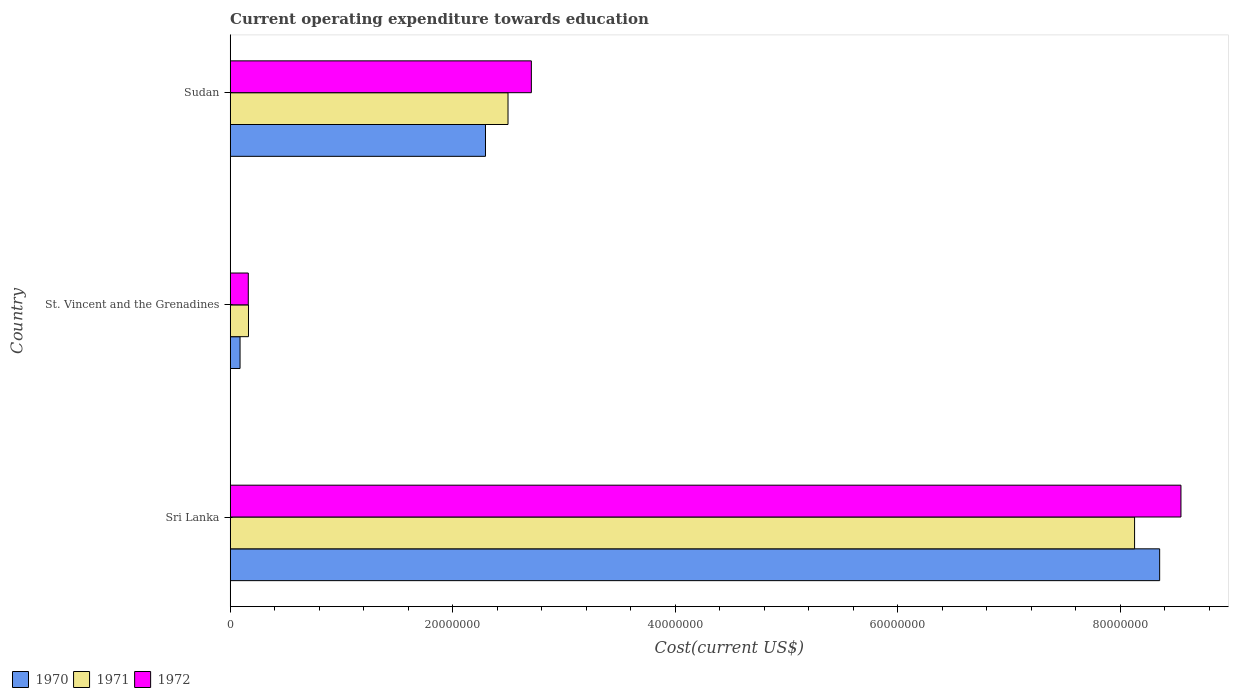How many different coloured bars are there?
Make the answer very short. 3. Are the number of bars on each tick of the Y-axis equal?
Ensure brevity in your answer.  Yes. How many bars are there on the 3rd tick from the bottom?
Keep it short and to the point. 3. What is the label of the 2nd group of bars from the top?
Your answer should be very brief. St. Vincent and the Grenadines. In how many cases, is the number of bars for a given country not equal to the number of legend labels?
Provide a short and direct response. 0. What is the expenditure towards education in 1970 in St. Vincent and the Grenadines?
Ensure brevity in your answer.  8.86e+05. Across all countries, what is the maximum expenditure towards education in 1970?
Keep it short and to the point. 8.35e+07. Across all countries, what is the minimum expenditure towards education in 1971?
Offer a very short reply. 1.64e+06. In which country was the expenditure towards education in 1970 maximum?
Offer a very short reply. Sri Lanka. In which country was the expenditure towards education in 1972 minimum?
Provide a short and direct response. St. Vincent and the Grenadines. What is the total expenditure towards education in 1972 in the graph?
Offer a very short reply. 1.14e+08. What is the difference between the expenditure towards education in 1971 in St. Vincent and the Grenadines and that in Sudan?
Make the answer very short. -2.33e+07. What is the difference between the expenditure towards education in 1971 in Sudan and the expenditure towards education in 1972 in St. Vincent and the Grenadines?
Your answer should be compact. 2.33e+07. What is the average expenditure towards education in 1972 per country?
Keep it short and to the point. 3.81e+07. What is the difference between the expenditure towards education in 1970 and expenditure towards education in 1972 in St. Vincent and the Grenadines?
Make the answer very short. -7.42e+05. What is the ratio of the expenditure towards education in 1972 in Sri Lanka to that in St. Vincent and the Grenadines?
Make the answer very short. 52.51. Is the expenditure towards education in 1972 in Sri Lanka less than that in St. Vincent and the Grenadines?
Offer a terse response. No. What is the difference between the highest and the second highest expenditure towards education in 1971?
Offer a very short reply. 5.63e+07. What is the difference between the highest and the lowest expenditure towards education in 1970?
Ensure brevity in your answer.  8.27e+07. What does the 3rd bar from the bottom in Sudan represents?
Provide a succinct answer. 1972. Is it the case that in every country, the sum of the expenditure towards education in 1970 and expenditure towards education in 1972 is greater than the expenditure towards education in 1971?
Give a very brief answer. Yes. Are all the bars in the graph horizontal?
Provide a short and direct response. Yes. What is the difference between two consecutive major ticks on the X-axis?
Your response must be concise. 2.00e+07. Are the values on the major ticks of X-axis written in scientific E-notation?
Give a very brief answer. No. Does the graph contain any zero values?
Make the answer very short. No. What is the title of the graph?
Provide a short and direct response. Current operating expenditure towards education. Does "1960" appear as one of the legend labels in the graph?
Provide a short and direct response. No. What is the label or title of the X-axis?
Give a very brief answer. Cost(current US$). What is the label or title of the Y-axis?
Offer a very short reply. Country. What is the Cost(current US$) in 1970 in Sri Lanka?
Make the answer very short. 8.35e+07. What is the Cost(current US$) of 1971 in Sri Lanka?
Provide a succinct answer. 8.13e+07. What is the Cost(current US$) of 1972 in Sri Lanka?
Make the answer very short. 8.55e+07. What is the Cost(current US$) of 1970 in St. Vincent and the Grenadines?
Make the answer very short. 8.86e+05. What is the Cost(current US$) in 1971 in St. Vincent and the Grenadines?
Keep it short and to the point. 1.64e+06. What is the Cost(current US$) in 1972 in St. Vincent and the Grenadines?
Provide a short and direct response. 1.63e+06. What is the Cost(current US$) in 1970 in Sudan?
Your answer should be compact. 2.29e+07. What is the Cost(current US$) of 1971 in Sudan?
Offer a terse response. 2.50e+07. What is the Cost(current US$) of 1972 in Sudan?
Offer a very short reply. 2.71e+07. Across all countries, what is the maximum Cost(current US$) in 1970?
Ensure brevity in your answer.  8.35e+07. Across all countries, what is the maximum Cost(current US$) in 1971?
Provide a succinct answer. 8.13e+07. Across all countries, what is the maximum Cost(current US$) in 1972?
Offer a very short reply. 8.55e+07. Across all countries, what is the minimum Cost(current US$) in 1970?
Give a very brief answer. 8.86e+05. Across all countries, what is the minimum Cost(current US$) of 1971?
Provide a succinct answer. 1.64e+06. Across all countries, what is the minimum Cost(current US$) of 1972?
Keep it short and to the point. 1.63e+06. What is the total Cost(current US$) of 1970 in the graph?
Ensure brevity in your answer.  1.07e+08. What is the total Cost(current US$) of 1971 in the graph?
Keep it short and to the point. 1.08e+08. What is the total Cost(current US$) in 1972 in the graph?
Provide a succinct answer. 1.14e+08. What is the difference between the Cost(current US$) of 1970 in Sri Lanka and that in St. Vincent and the Grenadines?
Ensure brevity in your answer.  8.27e+07. What is the difference between the Cost(current US$) of 1971 in Sri Lanka and that in St. Vincent and the Grenadines?
Your response must be concise. 7.96e+07. What is the difference between the Cost(current US$) in 1972 in Sri Lanka and that in St. Vincent and the Grenadines?
Keep it short and to the point. 8.38e+07. What is the difference between the Cost(current US$) in 1970 in Sri Lanka and that in Sudan?
Ensure brevity in your answer.  6.06e+07. What is the difference between the Cost(current US$) in 1971 in Sri Lanka and that in Sudan?
Provide a short and direct response. 5.63e+07. What is the difference between the Cost(current US$) in 1972 in Sri Lanka and that in Sudan?
Your answer should be compact. 5.84e+07. What is the difference between the Cost(current US$) in 1970 in St. Vincent and the Grenadines and that in Sudan?
Your answer should be very brief. -2.21e+07. What is the difference between the Cost(current US$) of 1971 in St. Vincent and the Grenadines and that in Sudan?
Provide a short and direct response. -2.33e+07. What is the difference between the Cost(current US$) in 1972 in St. Vincent and the Grenadines and that in Sudan?
Give a very brief answer. -2.54e+07. What is the difference between the Cost(current US$) in 1970 in Sri Lanka and the Cost(current US$) in 1971 in St. Vincent and the Grenadines?
Offer a very short reply. 8.19e+07. What is the difference between the Cost(current US$) in 1970 in Sri Lanka and the Cost(current US$) in 1972 in St. Vincent and the Grenadines?
Your answer should be very brief. 8.19e+07. What is the difference between the Cost(current US$) in 1971 in Sri Lanka and the Cost(current US$) in 1972 in St. Vincent and the Grenadines?
Offer a very short reply. 7.97e+07. What is the difference between the Cost(current US$) of 1970 in Sri Lanka and the Cost(current US$) of 1971 in Sudan?
Provide a short and direct response. 5.86e+07. What is the difference between the Cost(current US$) in 1970 in Sri Lanka and the Cost(current US$) in 1972 in Sudan?
Make the answer very short. 5.65e+07. What is the difference between the Cost(current US$) of 1971 in Sri Lanka and the Cost(current US$) of 1972 in Sudan?
Your answer should be very brief. 5.42e+07. What is the difference between the Cost(current US$) of 1970 in St. Vincent and the Grenadines and the Cost(current US$) of 1971 in Sudan?
Give a very brief answer. -2.41e+07. What is the difference between the Cost(current US$) in 1970 in St. Vincent and the Grenadines and the Cost(current US$) in 1972 in Sudan?
Keep it short and to the point. -2.62e+07. What is the difference between the Cost(current US$) in 1971 in St. Vincent and the Grenadines and the Cost(current US$) in 1972 in Sudan?
Provide a short and direct response. -2.54e+07. What is the average Cost(current US$) of 1970 per country?
Your answer should be compact. 3.58e+07. What is the average Cost(current US$) in 1971 per country?
Ensure brevity in your answer.  3.60e+07. What is the average Cost(current US$) in 1972 per country?
Your response must be concise. 3.81e+07. What is the difference between the Cost(current US$) in 1970 and Cost(current US$) in 1971 in Sri Lanka?
Ensure brevity in your answer.  2.25e+06. What is the difference between the Cost(current US$) in 1970 and Cost(current US$) in 1972 in Sri Lanka?
Provide a succinct answer. -1.91e+06. What is the difference between the Cost(current US$) of 1971 and Cost(current US$) of 1972 in Sri Lanka?
Give a very brief answer. -4.17e+06. What is the difference between the Cost(current US$) in 1970 and Cost(current US$) in 1971 in St. Vincent and the Grenadines?
Offer a very short reply. -7.59e+05. What is the difference between the Cost(current US$) of 1970 and Cost(current US$) of 1972 in St. Vincent and the Grenadines?
Keep it short and to the point. -7.42e+05. What is the difference between the Cost(current US$) in 1971 and Cost(current US$) in 1972 in St. Vincent and the Grenadines?
Provide a short and direct response. 1.67e+04. What is the difference between the Cost(current US$) in 1970 and Cost(current US$) in 1971 in Sudan?
Your answer should be compact. -2.02e+06. What is the difference between the Cost(current US$) of 1970 and Cost(current US$) of 1972 in Sudan?
Ensure brevity in your answer.  -4.12e+06. What is the difference between the Cost(current US$) in 1971 and Cost(current US$) in 1972 in Sudan?
Give a very brief answer. -2.10e+06. What is the ratio of the Cost(current US$) of 1970 in Sri Lanka to that in St. Vincent and the Grenadines?
Offer a terse response. 94.34. What is the ratio of the Cost(current US$) of 1971 in Sri Lanka to that in St. Vincent and the Grenadines?
Provide a short and direct response. 49.44. What is the ratio of the Cost(current US$) of 1972 in Sri Lanka to that in St. Vincent and the Grenadines?
Offer a very short reply. 52.51. What is the ratio of the Cost(current US$) of 1970 in Sri Lanka to that in Sudan?
Offer a very short reply. 3.64. What is the ratio of the Cost(current US$) in 1971 in Sri Lanka to that in Sudan?
Offer a terse response. 3.26. What is the ratio of the Cost(current US$) of 1972 in Sri Lanka to that in Sudan?
Provide a short and direct response. 3.16. What is the ratio of the Cost(current US$) in 1970 in St. Vincent and the Grenadines to that in Sudan?
Ensure brevity in your answer.  0.04. What is the ratio of the Cost(current US$) of 1971 in St. Vincent and the Grenadines to that in Sudan?
Offer a terse response. 0.07. What is the ratio of the Cost(current US$) in 1972 in St. Vincent and the Grenadines to that in Sudan?
Make the answer very short. 0.06. What is the difference between the highest and the second highest Cost(current US$) in 1970?
Your response must be concise. 6.06e+07. What is the difference between the highest and the second highest Cost(current US$) of 1971?
Your answer should be very brief. 5.63e+07. What is the difference between the highest and the second highest Cost(current US$) in 1972?
Keep it short and to the point. 5.84e+07. What is the difference between the highest and the lowest Cost(current US$) of 1970?
Ensure brevity in your answer.  8.27e+07. What is the difference between the highest and the lowest Cost(current US$) of 1971?
Provide a succinct answer. 7.96e+07. What is the difference between the highest and the lowest Cost(current US$) of 1972?
Make the answer very short. 8.38e+07. 